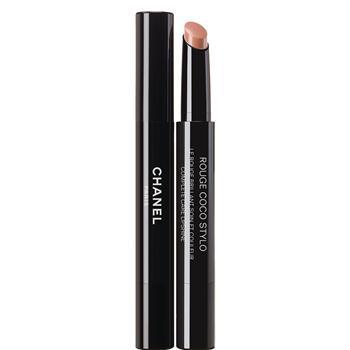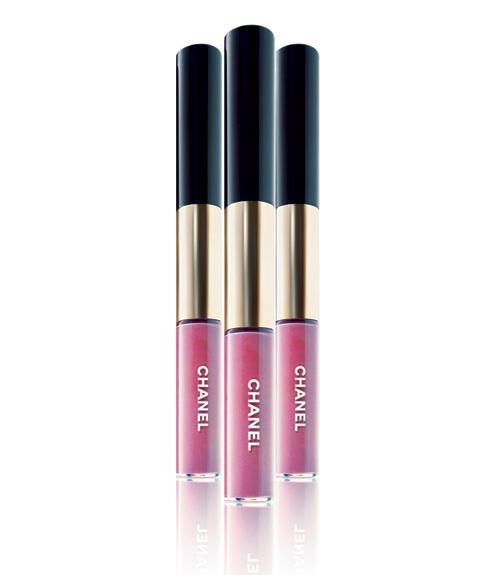The first image is the image on the left, the second image is the image on the right. Examine the images to the left and right. Is the description "There are at most 2 lipsticks in the image pair" accurate? Answer yes or no. No. The first image is the image on the left, the second image is the image on the right. Analyze the images presented: Is the assertion "All of the lipsticks shown are arranged parallel to one another, both within and across the two images." valid? Answer yes or no. Yes. 